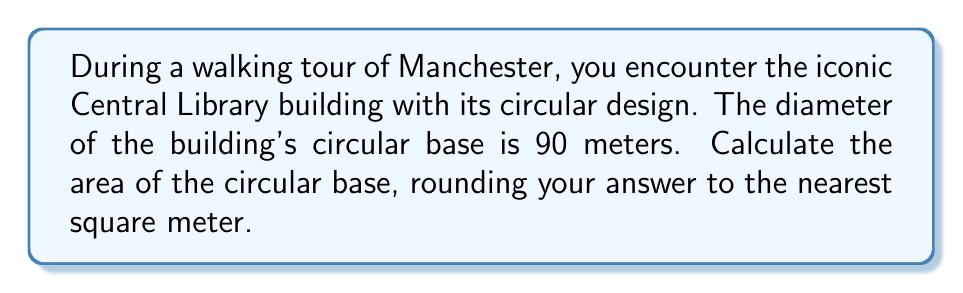Show me your answer to this math problem. To calculate the area of the circular base of Manchester's Central Library, we'll use the formula for the area of a circle:

$$A = \pi r^2$$

Where:
$A$ = area
$\pi$ = pi (approximately 3.14159)
$r$ = radius

Steps:
1. Find the radius:
   The diameter is 90 meters, so the radius is half of that.
   $$r = \frac{90}{2} = 45\text{ meters}$$

2. Apply the formula:
   $$A = \pi (45)^2$$

3. Calculate:
   $$A = \pi \cdot 2025 \approx 3.14159 \cdot 2025 \approx 6361.72\text{ square meters}$$

4. Round to the nearest square meter:
   $$A \approx 6362\text{ square meters}$$

[asy]
import geometry;

size(200);
fill(circle((0,0),45), rgb(0.9,0.9,0.9));
draw(circle((0,0),45));
draw((0,0)--(45,0), arrow=Arrow(TeXHead));
label("45 m", (22.5,2), N);
label("90 m", (0,-47), S);
draw((-45,0)--(45,0), dashed);
</asy]
Answer: 6362 m² 